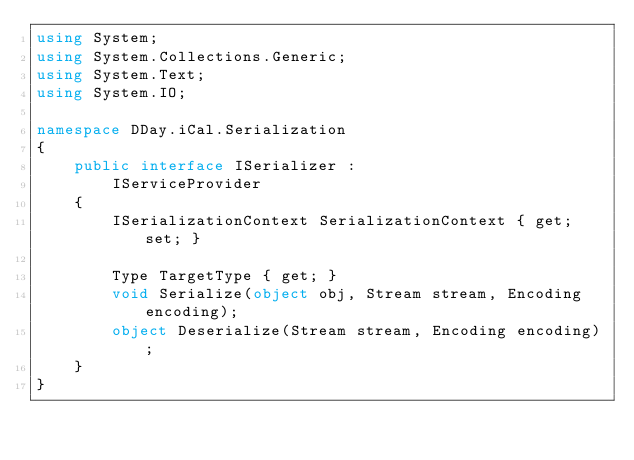Convert code to text. <code><loc_0><loc_0><loc_500><loc_500><_C#_>using System;
using System.Collections.Generic;
using System.Text;
using System.IO;

namespace DDay.iCal.Serialization
{    
    public interface ISerializer :
        IServiceProvider
    {
        ISerializationContext SerializationContext { get; set; }        

        Type TargetType { get; }        
        void Serialize(object obj, Stream stream, Encoding encoding);
        object Deserialize(Stream stream, Encoding encoding);
    }
}
</code> 